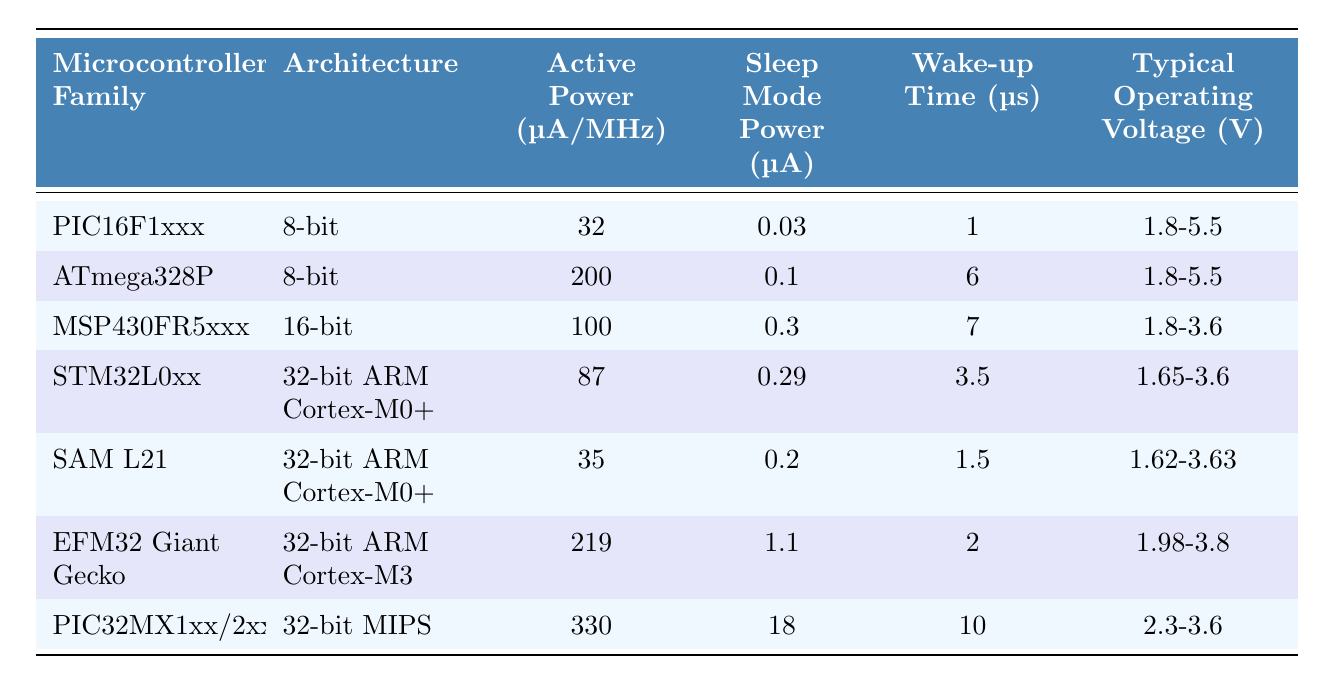What is the active power consumption of the PIC16F1xxx microcontroller? The table shows that the active power consumption for the PIC16F1xxx is listed as 32 µA/MHz.
Answer: 32 µA/MHz Which microcontroller family has the lowest sleep mode power? Comparing the sleep mode power values in the table, the PIC16F1xxx has the lowest value at 0.03 µA.
Answer: PIC16F1xxx What is the typical operating voltage range for the SAM L21 microcontroller? The SAM L21 has a typical operating voltage range displayed in the table as 1.62-3.63 V.
Answer: 1.62-3.63 V Does the STM32L0xx have a higher active power consumption than the MSP430FR5xxx? The active power consumption of STM32L0xx is 87 µA/MHz while the MSP430FR5xxx is 100 µA/MHz, meaning STM32L0xx has lower power consumption.
Answer: No What is the total wake-up time for the PIC32MX1xx/2xx? The table shows that the wake-up time for the PIC32MX1xx/2xx is 10 µs.
Answer: 10 µs Which microcontroller family has the highest active power consumption? The table lists the PIC32MX1xx/2xx with the highest active power consumption at 330 µA/MHz.
Answer: PIC32MX1xx/2xx Calculate the average active power consumption of the 32-bit ARM Cortex-M0+ microcontroller families. The active power for STM32L0xx is 87 µA/MHz and SAM L21 is 35 µA/MHz. The average is (87 + 35) / 2 = 61 µA/MHz.
Answer: 61 µA/MHz What microcontroller family has the longest wake-up time? According to the table, the PIC32MX1xx/2xx has the longest wake-up time at 10 µs compared to others.
Answer: PIC32MX1xx/2xx Is the sleep mode power of the EFM32 Giant Gecko greater than 1 µA? The sleep mode power for EFM32 Giant Gecko is 1.1 µA as seen in the table, which confirms it is greater.
Answer: Yes Which microcontroller family has the fastest wake-up time? The table shows that the PIC16F1xxx has the fastest wake-up time at 1 µs.
Answer: PIC16F1xxx 